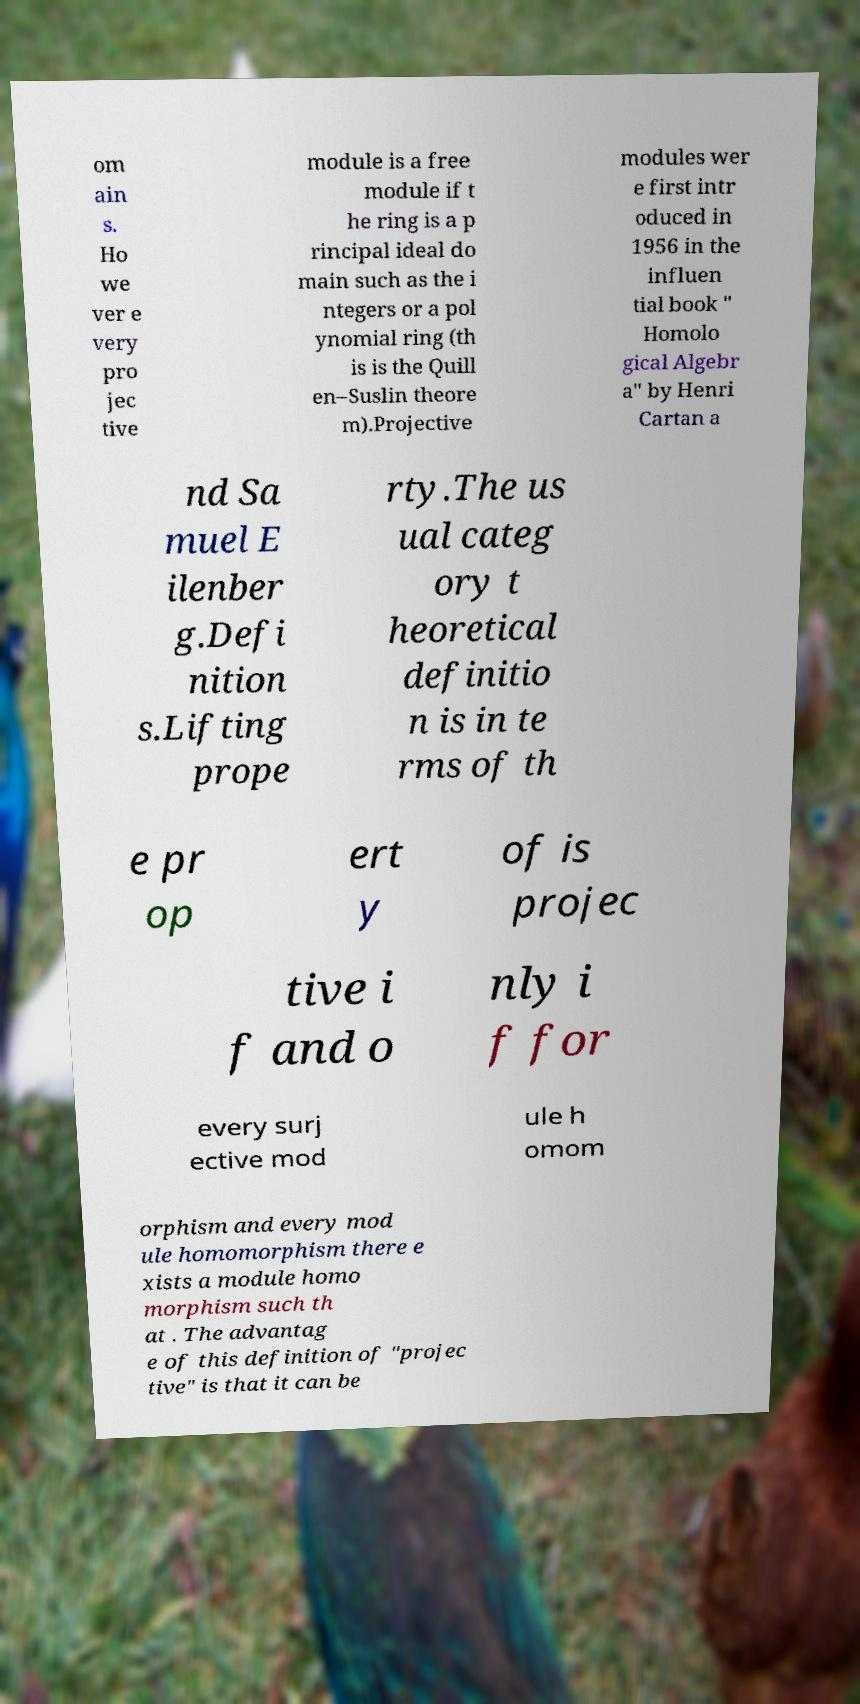Could you extract and type out the text from this image? om ain s. Ho we ver e very pro jec tive module is a free module if t he ring is a p rincipal ideal do main such as the i ntegers or a pol ynomial ring (th is is the Quill en–Suslin theore m).Projective modules wer e first intr oduced in 1956 in the influen tial book " Homolo gical Algebr a" by Henri Cartan a nd Sa muel E ilenber g.Defi nition s.Lifting prope rty.The us ual categ ory t heoretical definitio n is in te rms of th e pr op ert y of is projec tive i f and o nly i f for every surj ective mod ule h omom orphism and every mod ule homomorphism there e xists a module homo morphism such th at . The advantag e of this definition of "projec tive" is that it can be 